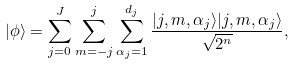Convert formula to latex. <formula><loc_0><loc_0><loc_500><loc_500>| \phi \rangle = \sum _ { j = 0 } ^ { J } \sum _ { m = - j } ^ { j } \sum _ { \alpha _ { j } = 1 } ^ { d _ { j } } \frac { | j , m , \alpha _ { j } \rangle | j , m , \alpha _ { j } \rangle } { \sqrt { 2 ^ { n } } } ,</formula> 